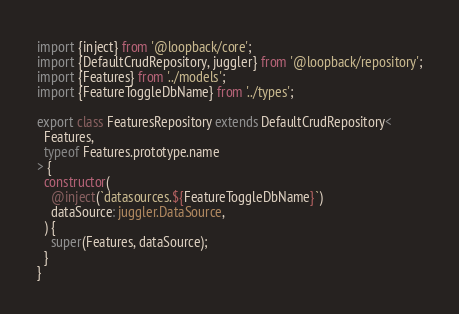Convert code to text. <code><loc_0><loc_0><loc_500><loc_500><_TypeScript_>import {inject} from '@loopback/core';
import {DefaultCrudRepository, juggler} from '@loopback/repository';
import {Features} from '../models';
import {FeatureToggleDbName} from '../types';

export class FeaturesRepository extends DefaultCrudRepository<
  Features,
  typeof Features.prototype.name
> {
  constructor(
    @inject(`datasources.${FeatureToggleDbName}`)
    dataSource: juggler.DataSource,
  ) {
    super(Features, dataSource);
  }
}
</code> 